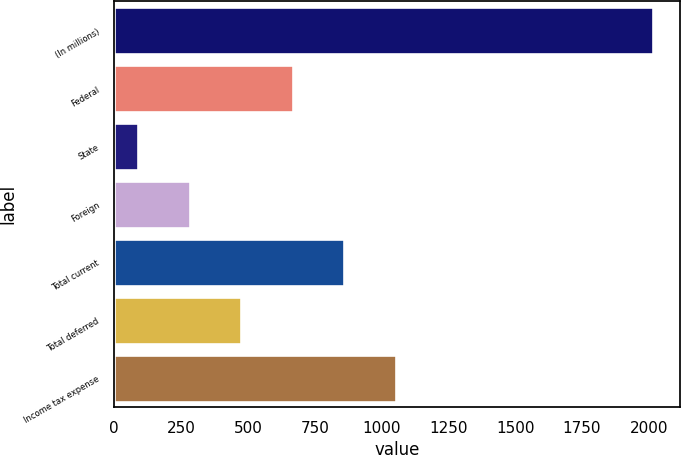<chart> <loc_0><loc_0><loc_500><loc_500><bar_chart><fcel>(In millions)<fcel>Federal<fcel>State<fcel>Foreign<fcel>Total current<fcel>Total deferred<fcel>Income tax expense<nl><fcel>2015<fcel>667.5<fcel>90<fcel>282.5<fcel>860<fcel>475<fcel>1052.5<nl></chart> 